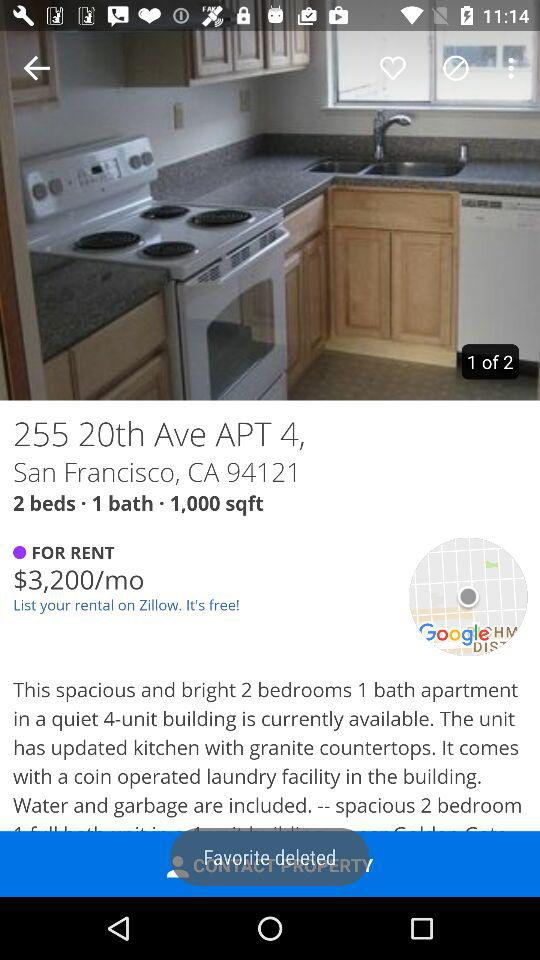How many bedrooms does the apartment have?
Answer the question using a single word or phrase. 2 